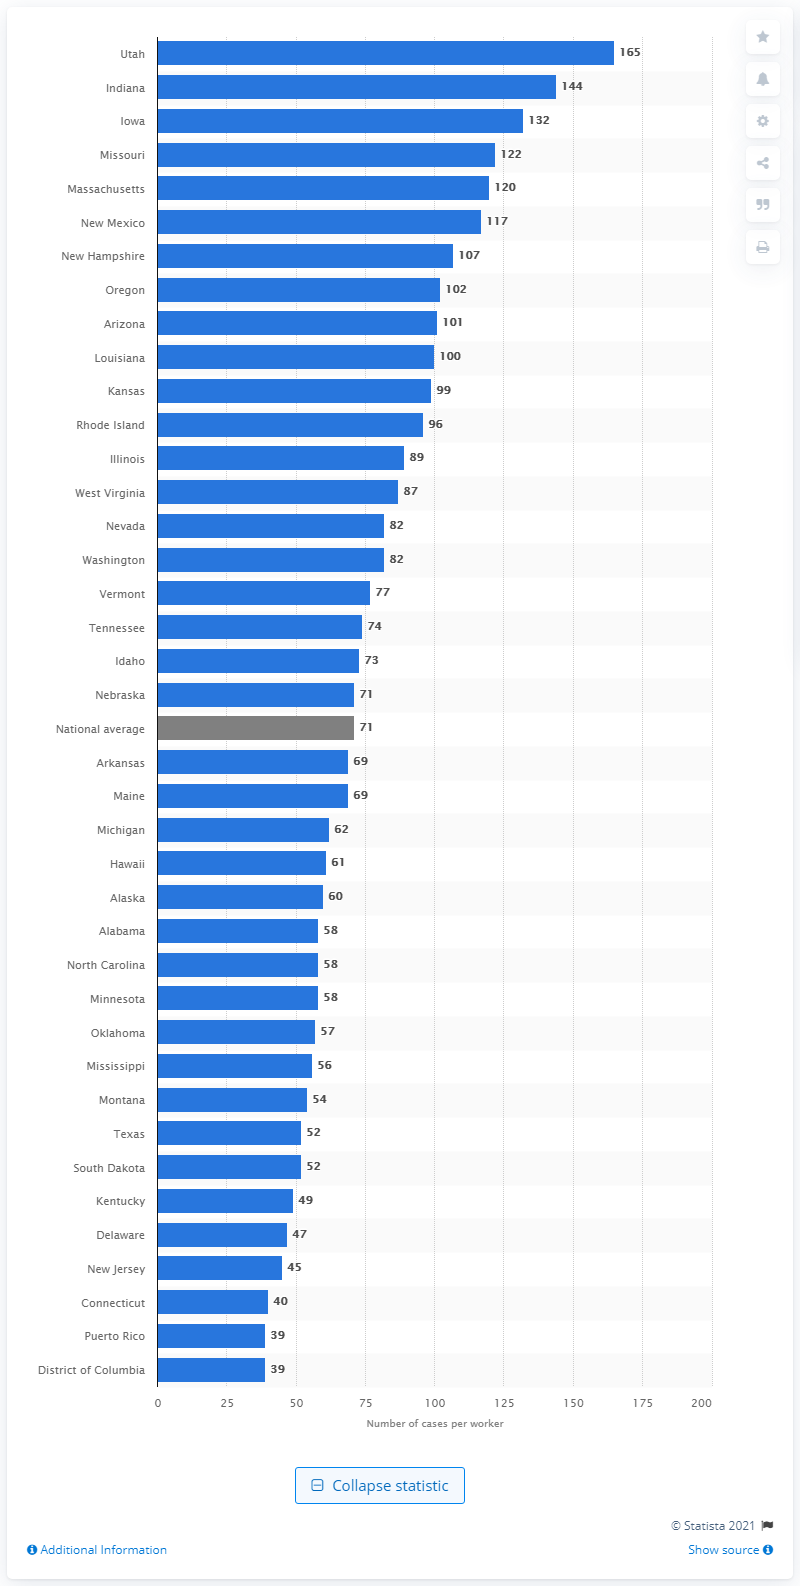Mention a couple of crucial points in this snapshot. In 2019, Vermont had an average of 77 cases. In 2019, the average number of cases handled by investigation and alternative response workers in Vermont was 77. 